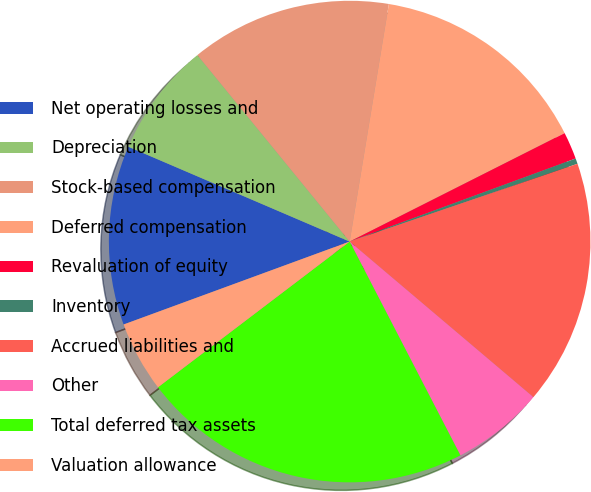Convert chart. <chart><loc_0><loc_0><loc_500><loc_500><pie_chart><fcel>Net operating losses and<fcel>Depreciation<fcel>Stock-based compensation<fcel>Deferred compensation<fcel>Revaluation of equity<fcel>Inventory<fcel>Accrued liabilities and<fcel>Other<fcel>Total deferred tax assets<fcel>Valuation allowance<nl><fcel>12.04%<fcel>7.66%<fcel>13.5%<fcel>14.96%<fcel>1.83%<fcel>0.37%<fcel>16.42%<fcel>6.21%<fcel>22.26%<fcel>4.75%<nl></chart> 